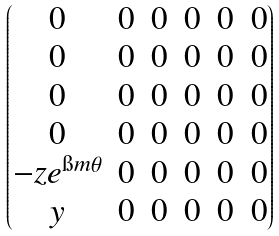<formula> <loc_0><loc_0><loc_500><loc_500>\begin{pmatrix} 0 & 0 & 0 & 0 & 0 & 0 \\ 0 & 0 & 0 & 0 & 0 & 0 \\ 0 & 0 & 0 & 0 & 0 & 0 \\ 0 & 0 & 0 & 0 & 0 & 0 \\ - z e ^ { \i m \theta } & 0 & 0 & 0 & 0 & 0 \\ y & 0 & 0 & 0 & 0 & 0 \end{pmatrix}</formula> 